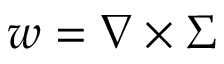<formula> <loc_0><loc_0><loc_500><loc_500>w = \nabla \times \Sigma</formula> 